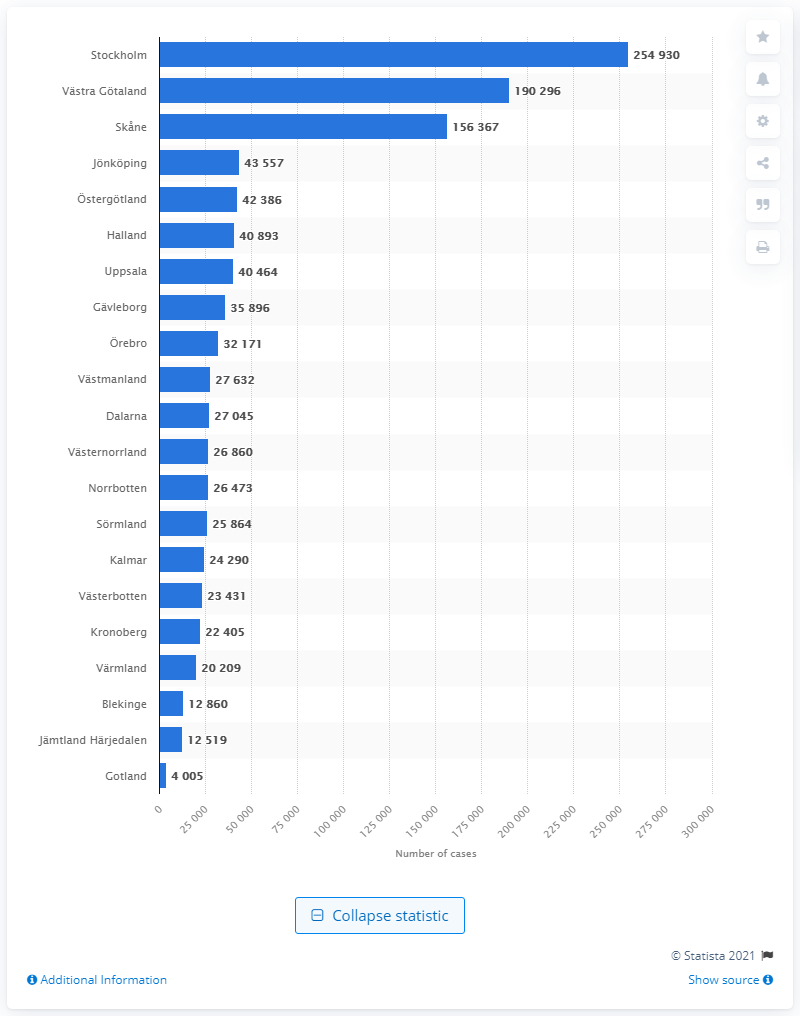Specify some key components in this picture. The highest number of confirmed cases of COVID-19 in Sweden as of June 9, 2021, was reported in Stockholm. 